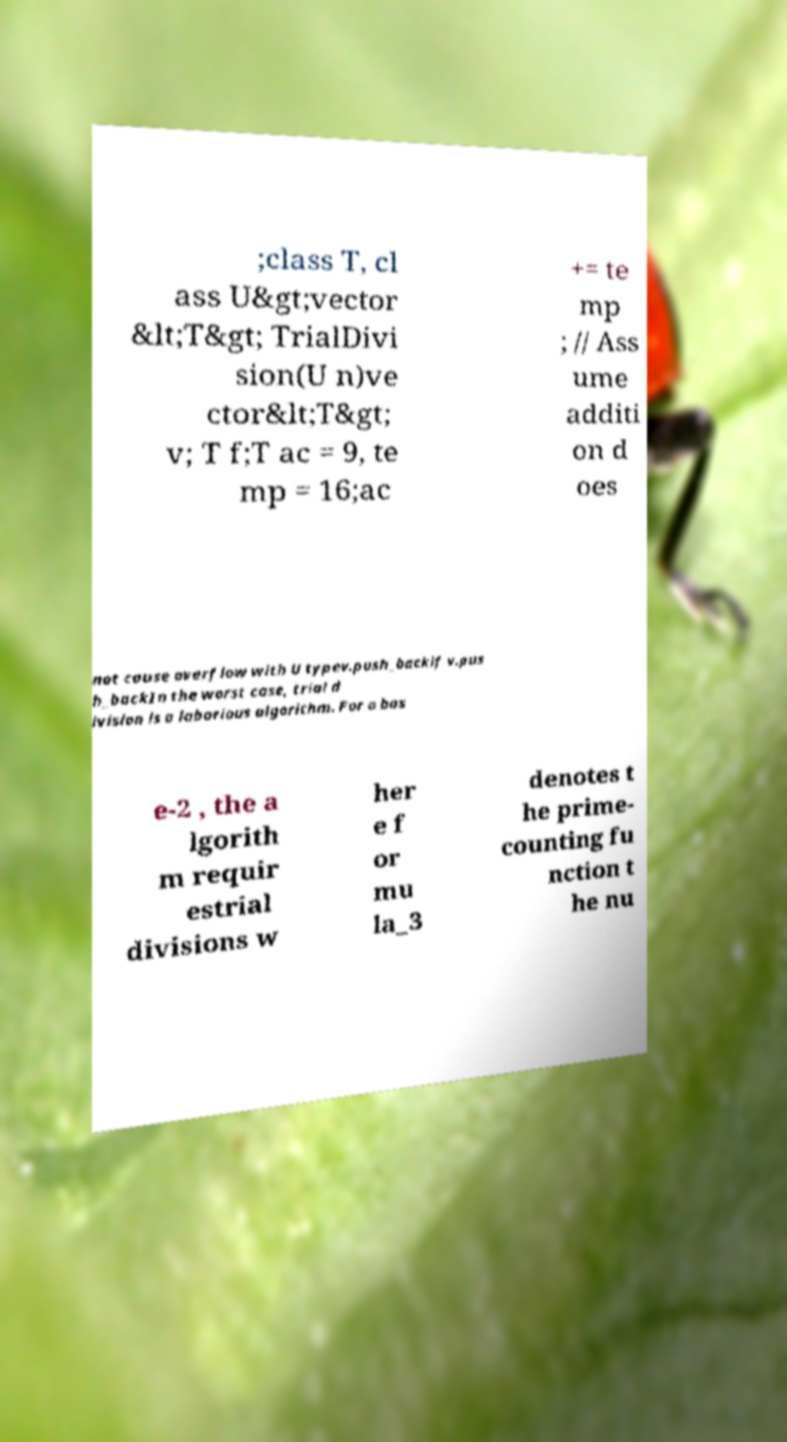What messages or text are displayed in this image? I need them in a readable, typed format. ;class T, cl ass U&gt;vector &lt;T&gt; TrialDivi sion(U n)ve ctor&lt;T&gt; v; T f;T ac = 9, te mp = 16;ac += te mp ; // Ass ume additi on d oes not cause overflow with U typev.push_backif v.pus h_backIn the worst case, trial d ivision is a laborious algorithm. For a bas e-2 , the a lgorith m requir estrial divisions w her e f or mu la_3 denotes t he prime- counting fu nction t he nu 